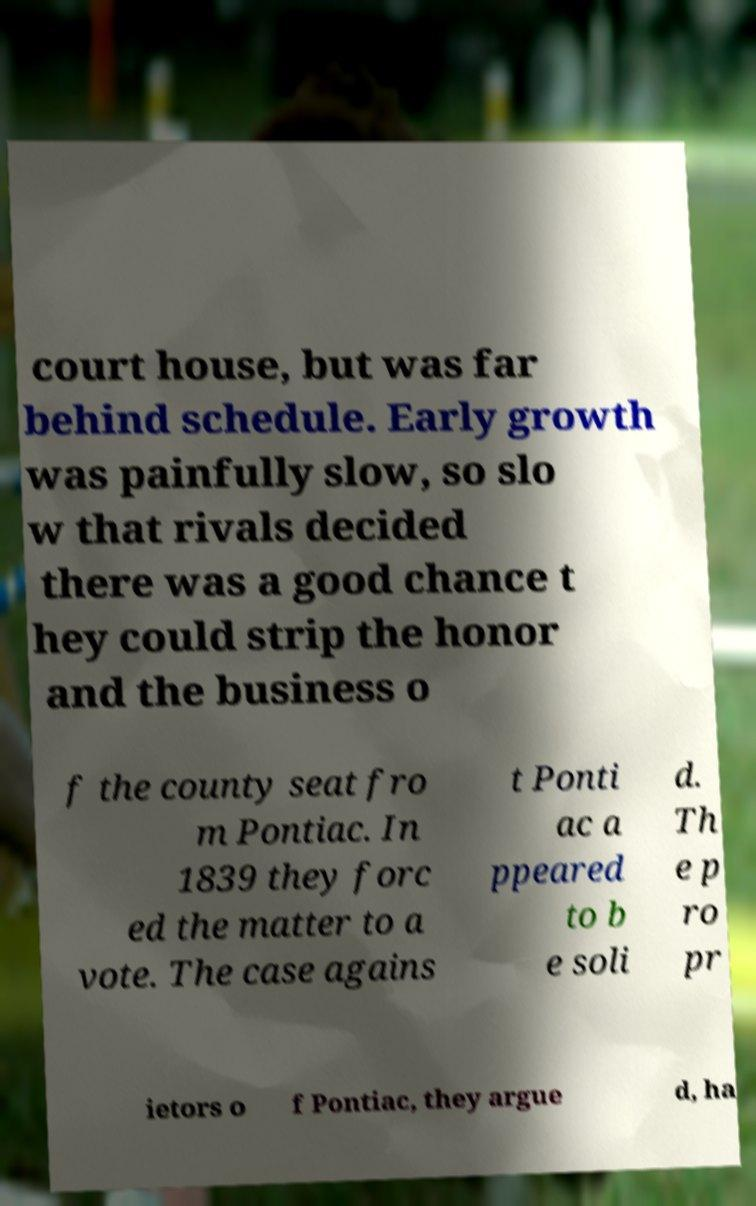Could you assist in decoding the text presented in this image and type it out clearly? court house, but was far behind schedule. Early growth was painfully slow, so slo w that rivals decided there was a good chance t hey could strip the honor and the business o f the county seat fro m Pontiac. In 1839 they forc ed the matter to a vote. The case agains t Ponti ac a ppeared to b e soli d. Th e p ro pr ietors o f Pontiac, they argue d, ha 